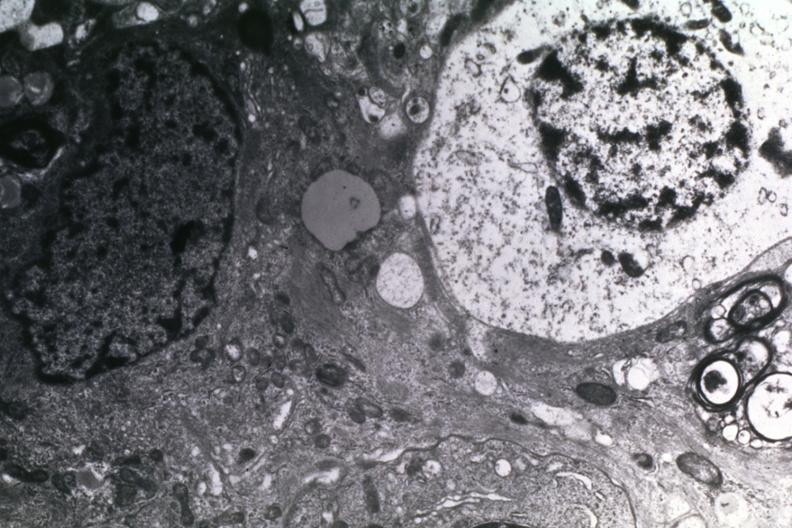what is present?
Answer the question using a single word or phrase. Brain 